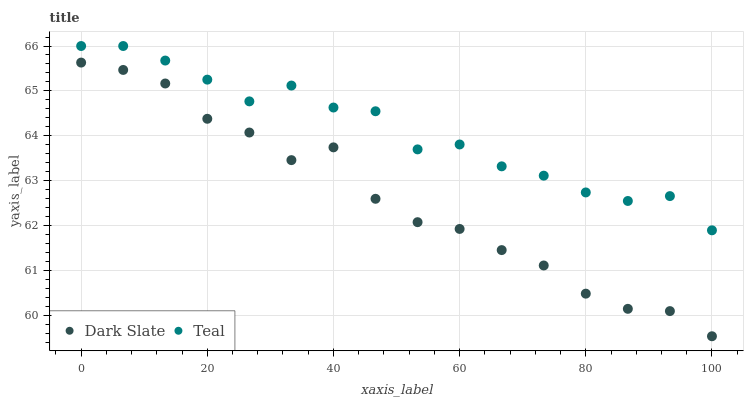Does Dark Slate have the minimum area under the curve?
Answer yes or no. Yes. Does Teal have the maximum area under the curve?
Answer yes or no. Yes. Does Teal have the minimum area under the curve?
Answer yes or no. No. Is Dark Slate the smoothest?
Answer yes or no. Yes. Is Teal the roughest?
Answer yes or no. Yes. Is Teal the smoothest?
Answer yes or no. No. Does Dark Slate have the lowest value?
Answer yes or no. Yes. Does Teal have the lowest value?
Answer yes or no. No. Does Teal have the highest value?
Answer yes or no. Yes. Is Dark Slate less than Teal?
Answer yes or no. Yes. Is Teal greater than Dark Slate?
Answer yes or no. Yes. Does Dark Slate intersect Teal?
Answer yes or no. No. 